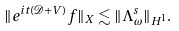<formula> <loc_0><loc_0><loc_500><loc_500>\| e ^ { i t ( \mathcal { D } + V ) } f \| _ { X } \lesssim \| \Lambda ^ { s } _ { \omega } \| _ { H ^ { 1 } } .</formula> 